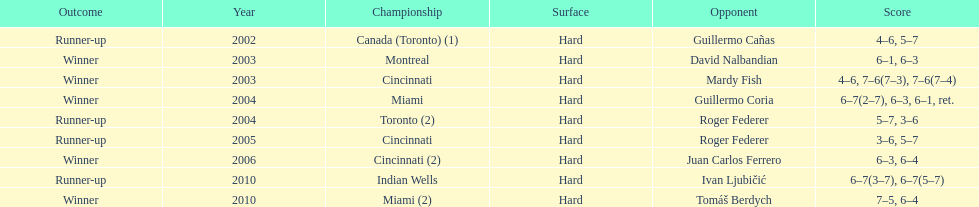What is his highest number of consecutive wins? 3. 